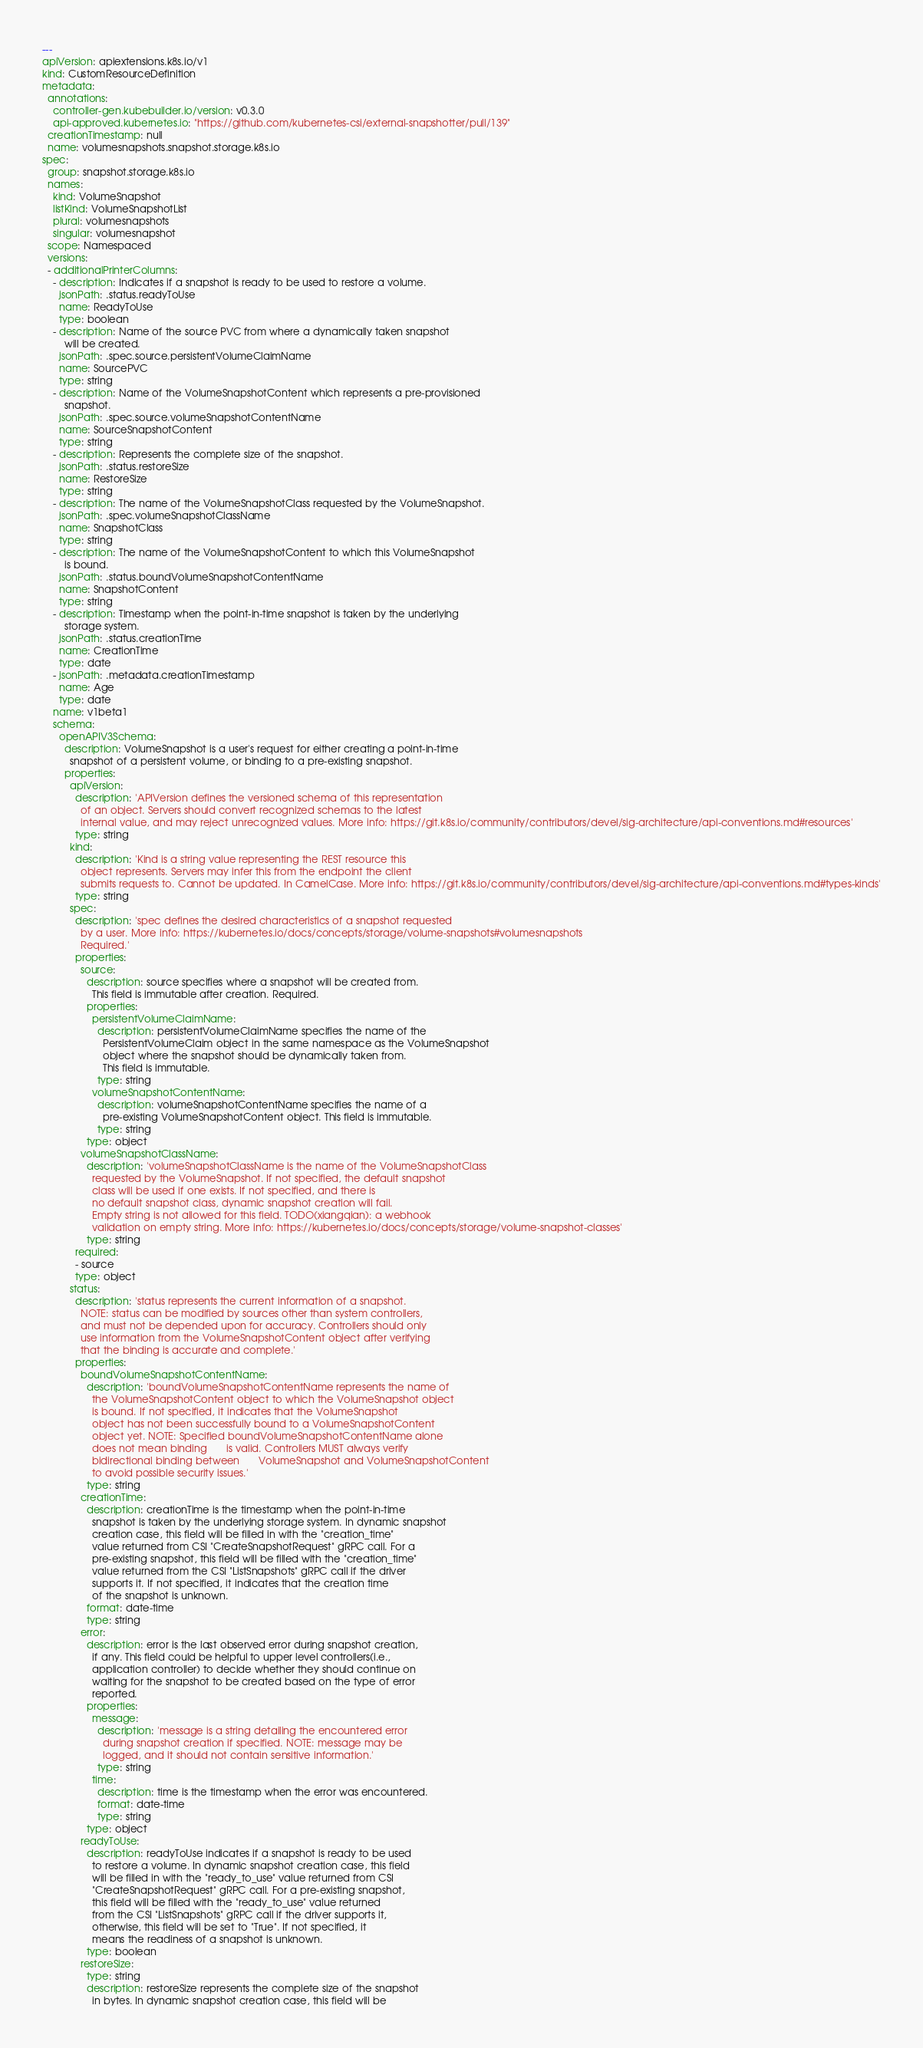<code> <loc_0><loc_0><loc_500><loc_500><_YAML_>
---
apiVersion: apiextensions.k8s.io/v1
kind: CustomResourceDefinition
metadata:
  annotations:
    controller-gen.kubebuilder.io/version: v0.3.0
    api-approved.kubernetes.io: "https://github.com/kubernetes-csi/external-snapshotter/pull/139"
  creationTimestamp: null
  name: volumesnapshots.snapshot.storage.k8s.io
spec:
  group: snapshot.storage.k8s.io
  names:
    kind: VolumeSnapshot
    listKind: VolumeSnapshotList
    plural: volumesnapshots
    singular: volumesnapshot
  scope: Namespaced
  versions:
  - additionalPrinterColumns:
    - description: Indicates if a snapshot is ready to be used to restore a volume.
      jsonPath: .status.readyToUse
      name: ReadyToUse
      type: boolean
    - description: Name of the source PVC from where a dynamically taken snapshot
        will be created.
      jsonPath: .spec.source.persistentVolumeClaimName
      name: SourcePVC
      type: string
    - description: Name of the VolumeSnapshotContent which represents a pre-provisioned
        snapshot.
      jsonPath: .spec.source.volumeSnapshotContentName
      name: SourceSnapshotContent
      type: string
    - description: Represents the complete size of the snapshot.
      jsonPath: .status.restoreSize
      name: RestoreSize
      type: string
    - description: The name of the VolumeSnapshotClass requested by the VolumeSnapshot.
      jsonPath: .spec.volumeSnapshotClassName
      name: SnapshotClass
      type: string
    - description: The name of the VolumeSnapshotContent to which this VolumeSnapshot
        is bound.
      jsonPath: .status.boundVolumeSnapshotContentName
      name: SnapshotContent
      type: string
    - description: Timestamp when the point-in-time snapshot is taken by the underlying
        storage system.
      jsonPath: .status.creationTime
      name: CreationTime
      type: date
    - jsonPath: .metadata.creationTimestamp
      name: Age
      type: date
    name: v1beta1
    schema:
      openAPIV3Schema:
        description: VolumeSnapshot is a user's request for either creating a point-in-time
          snapshot of a persistent volume, or binding to a pre-existing snapshot.
        properties:
          apiVersion:
            description: 'APIVersion defines the versioned schema of this representation
              of an object. Servers should convert recognized schemas to the latest
              internal value, and may reject unrecognized values. More info: https://git.k8s.io/community/contributors/devel/sig-architecture/api-conventions.md#resources'
            type: string
          kind:
            description: 'Kind is a string value representing the REST resource this
              object represents. Servers may infer this from the endpoint the client
              submits requests to. Cannot be updated. In CamelCase. More info: https://git.k8s.io/community/contributors/devel/sig-architecture/api-conventions.md#types-kinds'
            type: string
          spec:
            description: 'spec defines the desired characteristics of a snapshot requested
              by a user. More info: https://kubernetes.io/docs/concepts/storage/volume-snapshots#volumesnapshots
              Required.'
            properties:
              source:
                description: source specifies where a snapshot will be created from.
                  This field is immutable after creation. Required.
                properties:
                  persistentVolumeClaimName:
                    description: persistentVolumeClaimName specifies the name of the
                      PersistentVolumeClaim object in the same namespace as the VolumeSnapshot
                      object where the snapshot should be dynamically taken from.
                      This field is immutable.
                    type: string
                  volumeSnapshotContentName:
                    description: volumeSnapshotContentName specifies the name of a
                      pre-existing VolumeSnapshotContent object. This field is immutable.
                    type: string
                type: object
              volumeSnapshotClassName:
                description: 'volumeSnapshotClassName is the name of the VolumeSnapshotClass
                  requested by the VolumeSnapshot. If not specified, the default snapshot
                  class will be used if one exists. If not specified, and there is
                  no default snapshot class, dynamic snapshot creation will fail.
                  Empty string is not allowed for this field. TODO(xiangqian): a webhook
                  validation on empty string. More info: https://kubernetes.io/docs/concepts/storage/volume-snapshot-classes'
                type: string
            required:
            - source
            type: object
          status:
            description: 'status represents the current information of a snapshot.
              NOTE: status can be modified by sources other than system controllers,
              and must not be depended upon for accuracy. Controllers should only
              use information from the VolumeSnapshotContent object after verifying
              that the binding is accurate and complete.'
            properties:
              boundVolumeSnapshotContentName:
                description: 'boundVolumeSnapshotContentName represents the name of
                  the VolumeSnapshotContent object to which the VolumeSnapshot object
                  is bound. If not specified, it indicates that the VolumeSnapshot
                  object has not been successfully bound to a VolumeSnapshotContent
                  object yet. NOTE: Specified boundVolumeSnapshotContentName alone
                  does not mean binding       is valid. Controllers MUST always verify
                  bidirectional binding between       VolumeSnapshot and VolumeSnapshotContent
                  to avoid possible security issues.'
                type: string
              creationTime:
                description: creationTime is the timestamp when the point-in-time
                  snapshot is taken by the underlying storage system. In dynamic snapshot
                  creation case, this field will be filled in with the "creation_time"
                  value returned from CSI "CreateSnapshotRequest" gRPC call. For a
                  pre-existing snapshot, this field will be filled with the "creation_time"
                  value returned from the CSI "ListSnapshots" gRPC call if the driver
                  supports it. If not specified, it indicates that the creation time
                  of the snapshot is unknown.
                format: date-time
                type: string
              error:
                description: error is the last observed error during snapshot creation,
                  if any. This field could be helpful to upper level controllers(i.e.,
                  application controller) to decide whether they should continue on
                  waiting for the snapshot to be created based on the type of error
                  reported.
                properties:
                  message:
                    description: 'message is a string detailing the encountered error
                      during snapshot creation if specified. NOTE: message may be
                      logged, and it should not contain sensitive information.'
                    type: string
                  time:
                    description: time is the timestamp when the error was encountered.
                    format: date-time
                    type: string
                type: object
              readyToUse:
                description: readyToUse indicates if a snapshot is ready to be used
                  to restore a volume. In dynamic snapshot creation case, this field
                  will be filled in with the "ready_to_use" value returned from CSI
                  "CreateSnapshotRequest" gRPC call. For a pre-existing snapshot,
                  this field will be filled with the "ready_to_use" value returned
                  from the CSI "ListSnapshots" gRPC call if the driver supports it,
                  otherwise, this field will be set to "True". If not specified, it
                  means the readiness of a snapshot is unknown.
                type: boolean
              restoreSize:
                type: string
                description: restoreSize represents the complete size of the snapshot
                  in bytes. In dynamic snapshot creation case, this field will be</code> 